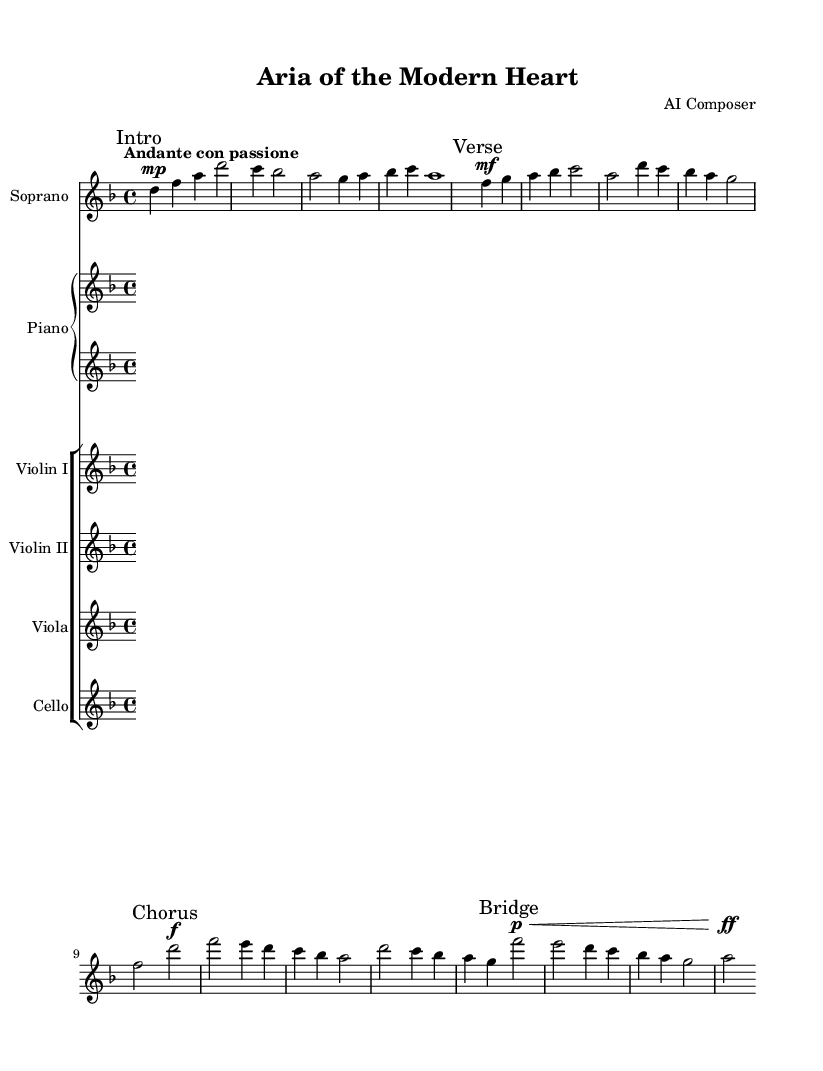What is the key signature of this music? The key signature indicates the music is in D minor, as it includes one flat (B flat), which is characteristic of the D minor scale.
Answer: D minor What is the time signature of this piece? The time signature shown on the sheet music is 4/4, which means four beats per measure and a quarter note receives one beat.
Answer: 4/4 What is the tempo marking of this composition? The tempo marking indicates "Andante con passione," which signifies a moderately slow tempo with a sense of passion or emotion.
Answer: Andante con passione How many measures are there in the introduction? In the introduction section, there are four measures, which can be counted from the start of the music leading up to the first repeat mark.
Answer: Four What dynamics are indicated at the beginning of the chorus? The dynamics at the beginning of the chorus are marked with "f," which indicates that the music should be played loudly, bringing an emotive intensity to this section.
Answer: f How does the bridge differ in dynamics compared to the verse? The bridge section starts with a soft dynamic marked by "p," which contrasts with the verse that is marked "mf" (mezzo-forte), indicating a moderately loud dynamic. This shift creates a more intimate feel before moving into the more powerful chorus.
Answer: Softer 